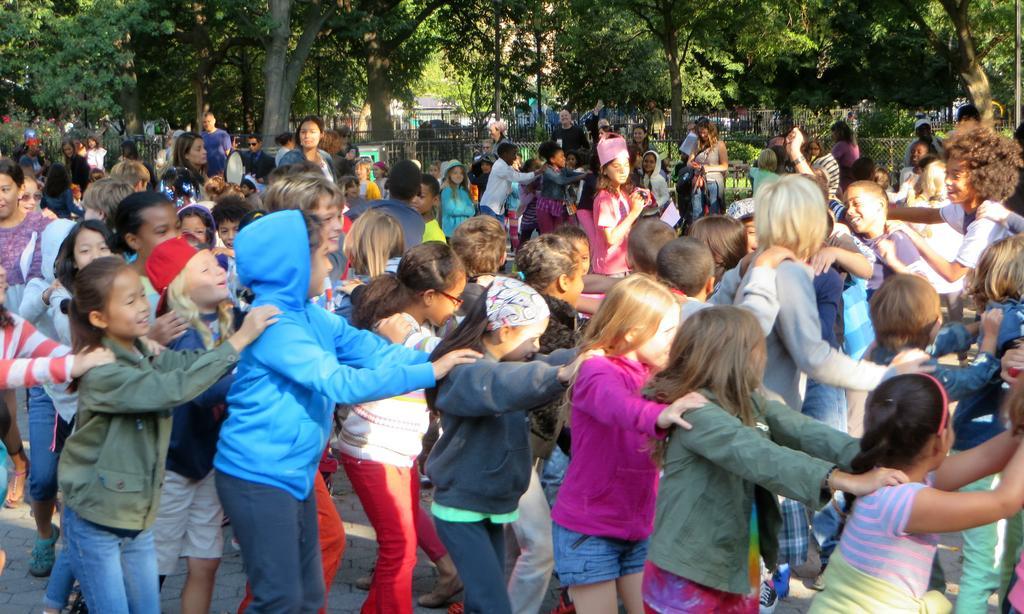Please provide a concise description of this image. In the picture we can see many children are playing on the road. In the background, we can see the fence, plants and trees. 